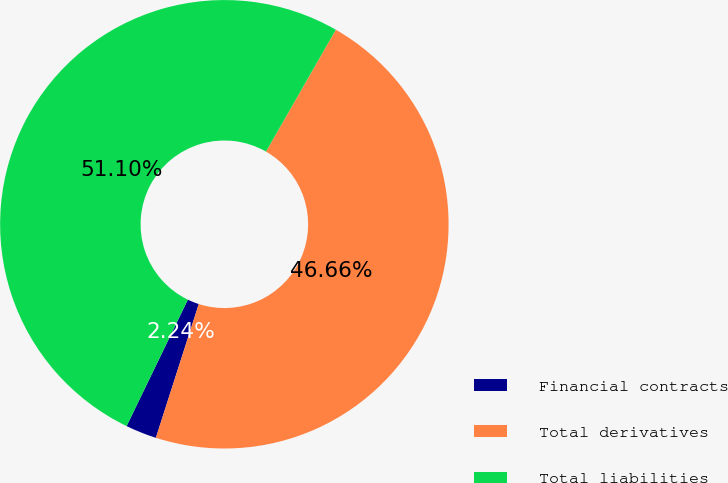<chart> <loc_0><loc_0><loc_500><loc_500><pie_chart><fcel>Financial contracts<fcel>Total derivatives<fcel>Total liabilities<nl><fcel>2.24%<fcel>46.66%<fcel>51.1%<nl></chart> 